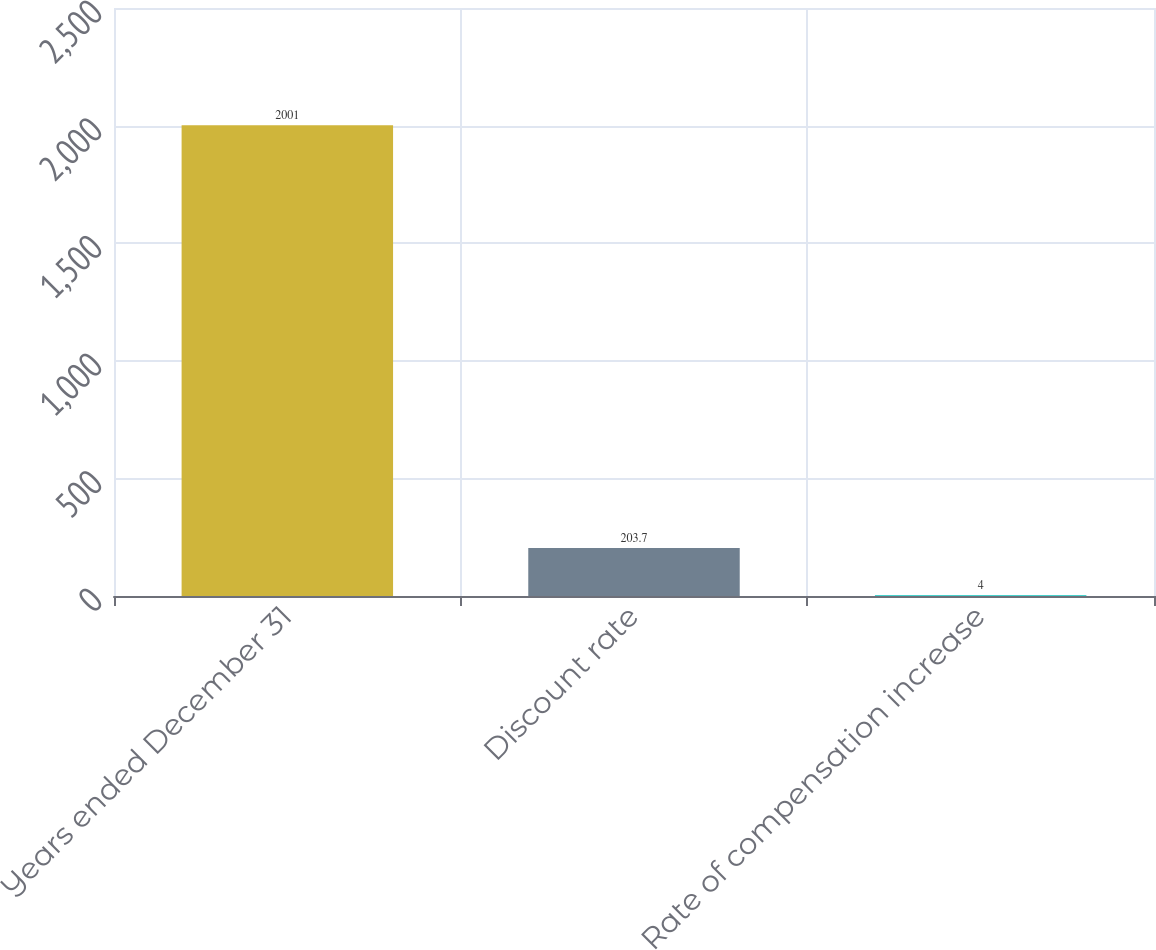Convert chart to OTSL. <chart><loc_0><loc_0><loc_500><loc_500><bar_chart><fcel>Years ended December 31<fcel>Discount rate<fcel>Rate of compensation increase<nl><fcel>2001<fcel>203.7<fcel>4<nl></chart> 